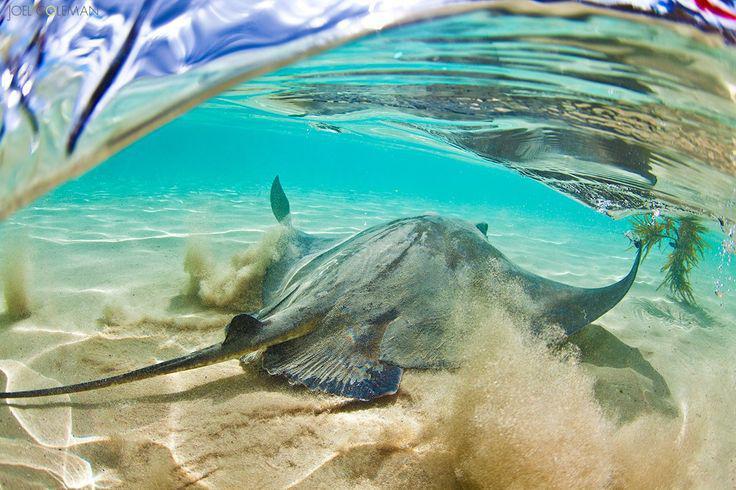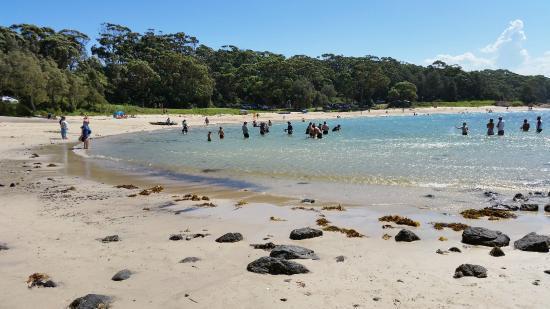The first image is the image on the left, the second image is the image on the right. Assess this claim about the two images: "A man is interacting with a sea animal in the water.". Correct or not? Answer yes or no. No. The first image is the image on the left, the second image is the image on the right. Given the left and right images, does the statement "An image shows one man standing in water and bending toward a stingray." hold true? Answer yes or no. No. 